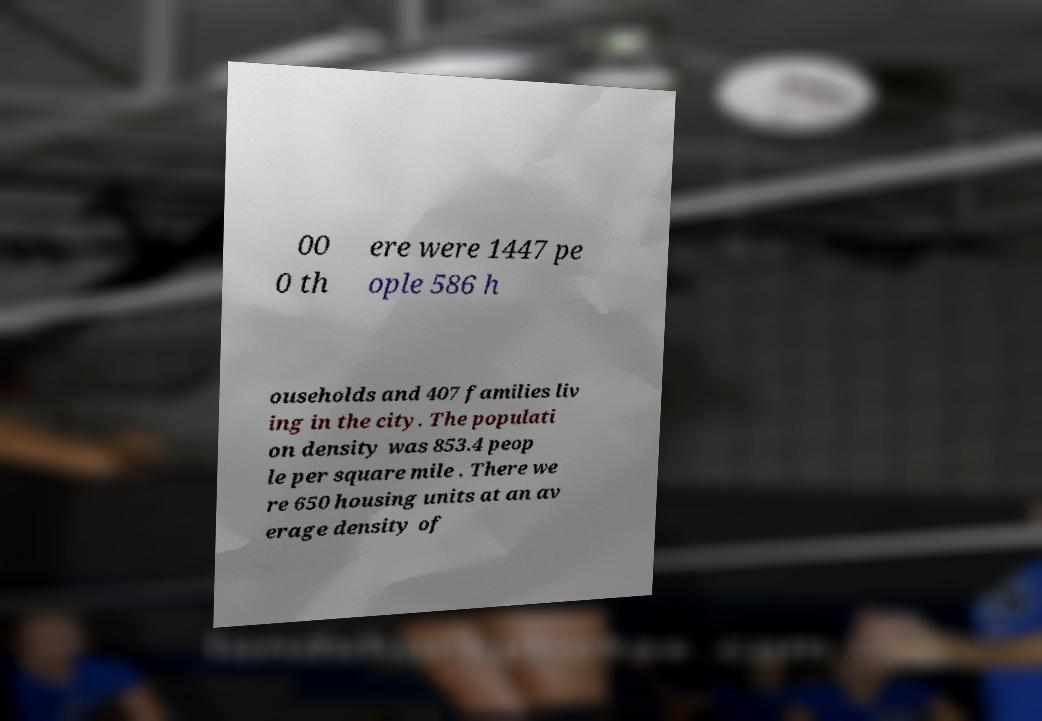There's text embedded in this image that I need extracted. Can you transcribe it verbatim? 00 0 th ere were 1447 pe ople 586 h ouseholds and 407 families liv ing in the city. The populati on density was 853.4 peop le per square mile . There we re 650 housing units at an av erage density of 